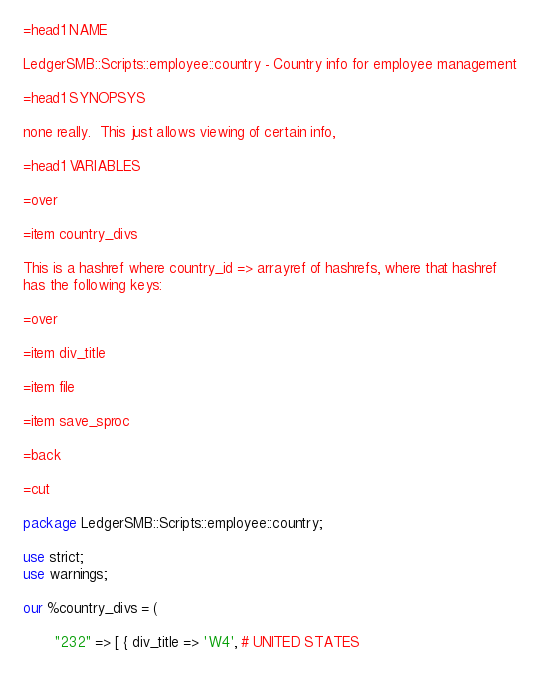Convert code to text. <code><loc_0><loc_0><loc_500><loc_500><_Perl_>=head1 NAME

LedgerSMB::Scripts::employee::country - Country info for employee management

=head1 SYNOPSYS

none really.  This just allows viewing of certain info,

=head1 VARIABLES

=over

=item country_divs

This is a hashref where country_id => arrayref of hashrefs, where that hashref
has the following keys:

=over

=item div_title

=item file

=item save_sproc

=back

=cut

package LedgerSMB::Scripts::employee::country;

use strict;
use warnings;

our %country_divs = (

       "232" => [ { div_title => 'W4', # UNITED STATES</code> 